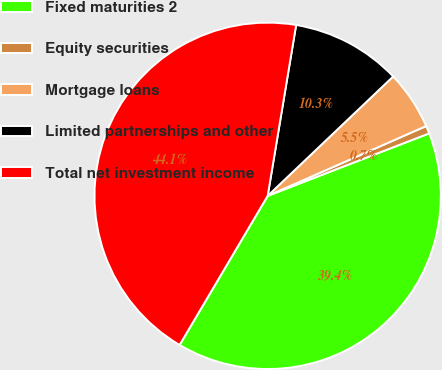Convert chart to OTSL. <chart><loc_0><loc_0><loc_500><loc_500><pie_chart><fcel>Fixed maturities 2<fcel>Equity securities<fcel>Mortgage loans<fcel>Limited partnerships and other<fcel>Total net investment income<nl><fcel>39.37%<fcel>0.73%<fcel>5.5%<fcel>10.27%<fcel>44.14%<nl></chart> 